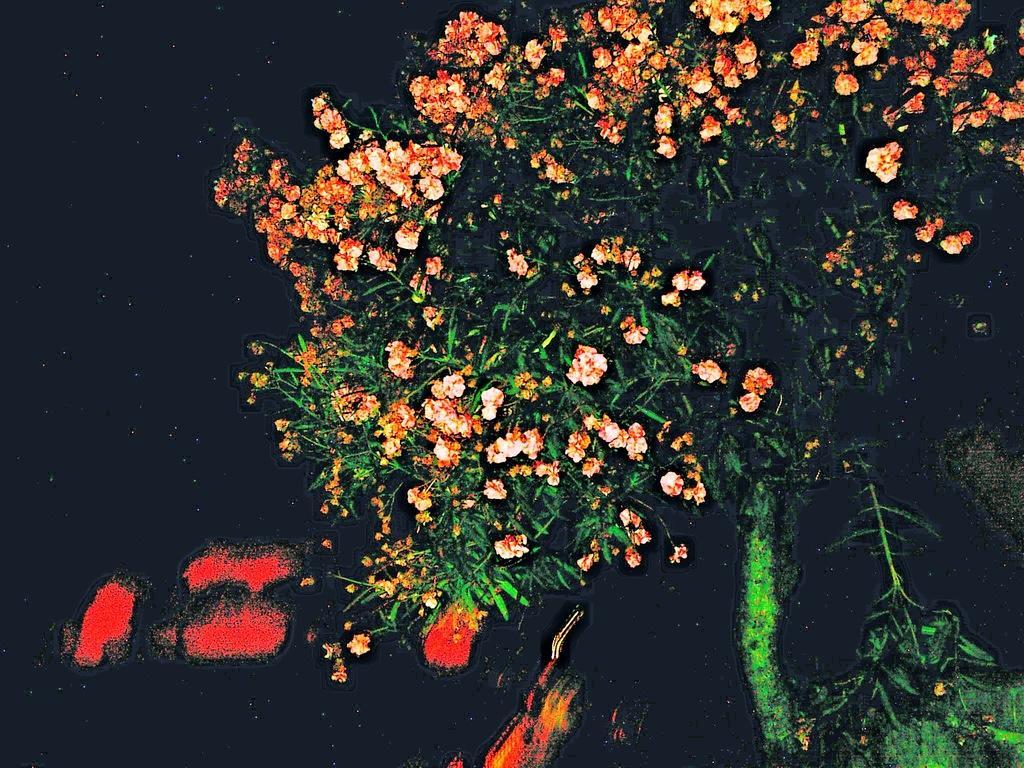Please provide a concise description of this image. In this image we can see the painting, in that there is a tree, flowers, and the background is dark. 